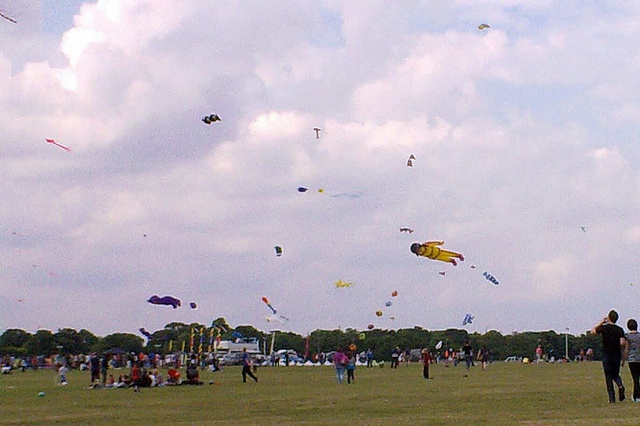Describe the objects in this image and their specific colors. I can see people in darkgray, black, gray, olive, and maroon tones, people in darkgray, black, and gray tones, kite in darkgray and lavender tones, people in darkgray, black, gray, and maroon tones, and kite in darkgray, olive, and maroon tones in this image. 